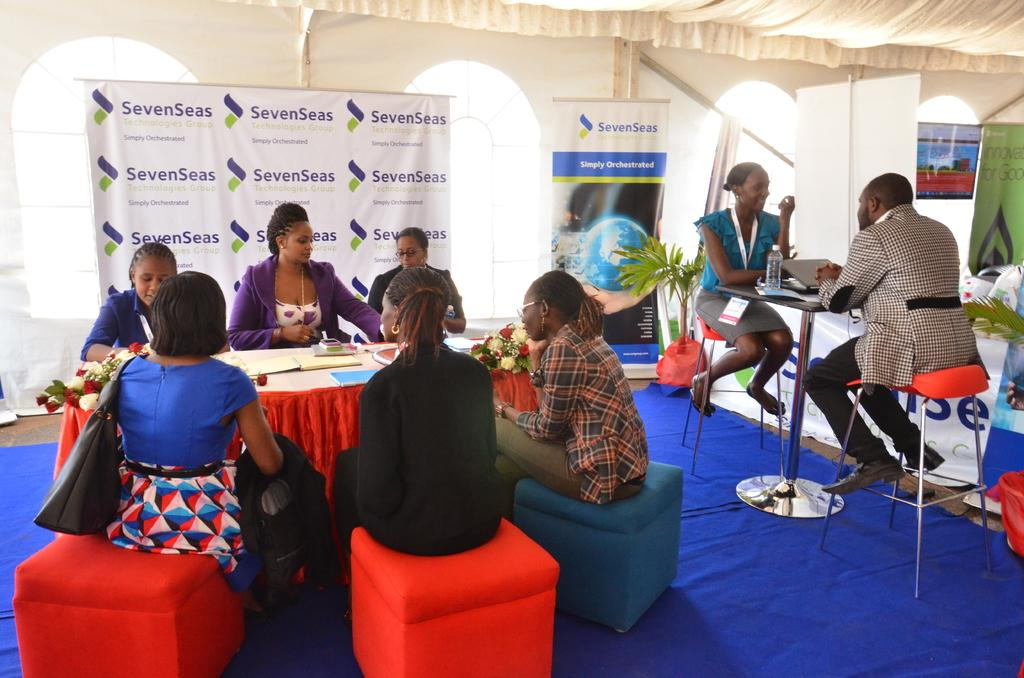How many people are sitting on chairs on the right side of the image? There are two persons sitting on chairs on the right side of the image. What are the two persons on the right side of the image doing? The two persons on the right side of the image are talking to each other. How many people are sitting around a table on the left side of the image? There are six persons sitting around a table on the left side of the image. What can be seen behind the six persons sitting around the table? There is a banner behind the six persons. What type of soda is being served at the table in the image? There is no soda present in the image. How can you tell that the six persons sitting around the table are quiet? The image does not provide any information about the noise level or the conversation of the six persons sitting around the table. 